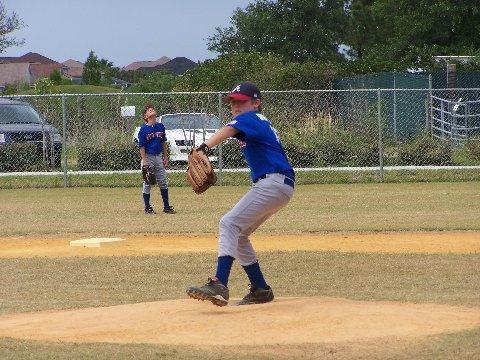How many tennis rackets do you see?
Give a very brief answer. 0. How many people can be seen?
Give a very brief answer. 2. How many cars can you see?
Give a very brief answer. 2. 